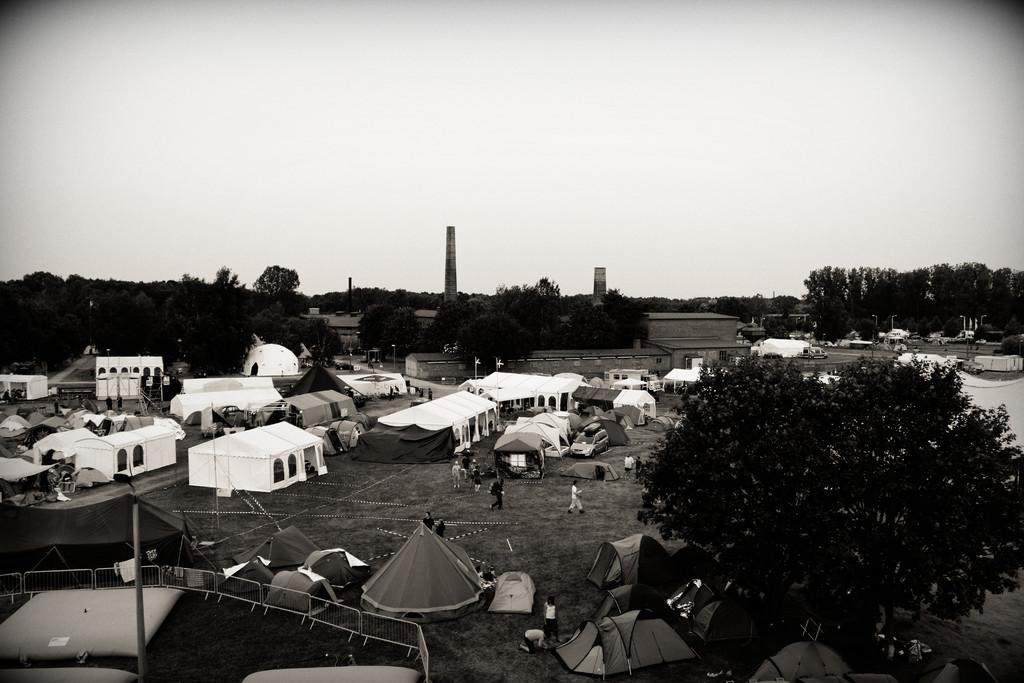What type of plant can be seen in the image? There is a tree in the image. What type of temporary shelters are visible in the image? There are tents in the image. What type of barrier is present in the image? There is a fence in the image. What type of vertical structures can be seen in the image? There are poles in the image. Who is present in the image? There are people in the image. What type of vehicle is visible in the image? There is a car in the image. What type of buildings can be seen in the background of the image? There are houses in the background of the image. What type of vegetation can be seen in the background of the image? There are trees in the background of the image. What type of vertical structures can be seen in the background of the image? There are poles in the background of the image. What is visible in the background of the image? The sky is visible in the background of the image. What type of vegetable is being used to create a scarf for the mother in the image? There is no vegetable or mother present in the image, and therefore no such activity can be observed. 